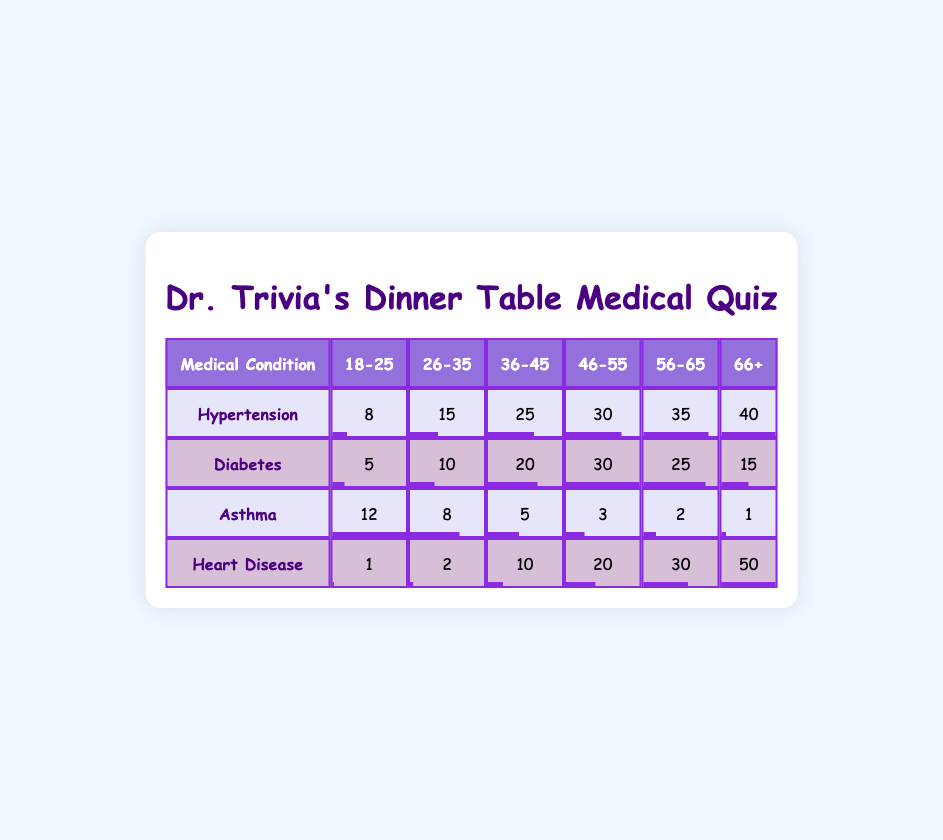What is the frequency of Hypertension reported by the 66+ age group? The table directly lists the frequency of Hypertension under the 66+ age group, which is 40.
Answer: 40 Which age group reported the highest frequency of Heart Disease? The highest frequency of Heart Disease is reported in the 66+ age group, with a frequency of 50.
Answer: 66+ What is the total frequency of Diabetes reported across all age groups? To find the total frequency of Diabetes, we add the frequencies for all age groups: 5 + 10 + 20 + 30 + 25 + 15 = 105.
Answer: 105 What condition has the lowest frequency reported for the 18-25 age group? The lowest frequency in the 18-25 age group is for Heart Disease, which only has a frequency of 1, compared to other conditions.
Answer: Heart Disease Is the frequency of Asthma higher in the 18-25 age group than in the 66+ age group? The frequency of Asthma in the 18-25 age group is 12, while in the 66+ age group it is only 1. Therefore, Asthma is higher in the younger group.
Answer: Yes What is the average frequency of Hypertension across all age groups? The average frequency is calculated by summing all frequencies: 8 + 15 + 25 + 30 + 35 + 40 = 153, and then dividing by the number of age groups (6): 153 / 6 = 25.5.
Answer: 25.5 How many more people reported having Hypertension compared to Diabetes in the 46-55 age group? The frequencies are 30 for Hypertension and 30 for Diabetes age group 46-55. The difference is 30 - 30 = 0.
Answer: 0 What condition in the 56-65 age group has the second-highest frequency? In the 56-65 age group, Heart Disease has 30 and Diabetes has 25; thus, Diabetes is the second highest after Heart Disease.
Answer: Diabetes What percentage of the people aged 66+ have Heart Disease compared to those with Hypertension in the same age group? The frequency for Heart Disease in the 66+ age group is 50, and for Hypertension, it is 40. To find the percentage, (50 / 40) * 100 = 125%.
Answer: 125% 